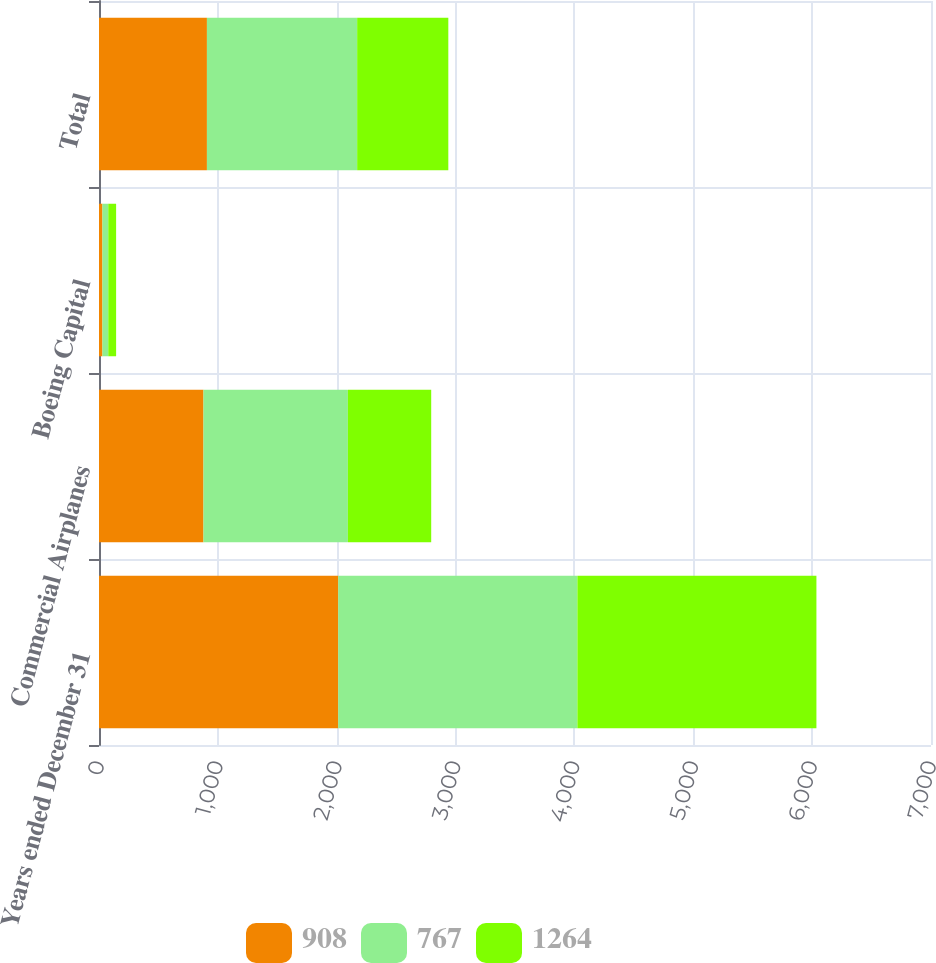Convert chart to OTSL. <chart><loc_0><loc_0><loc_500><loc_500><stacked_bar_chart><ecel><fcel>Years ended December 31<fcel>Commercial Airplanes<fcel>Boeing Capital<fcel>Total<nl><fcel>908<fcel>2013<fcel>879<fcel>29<fcel>908<nl><fcel>767<fcel>2012<fcel>1215<fcel>49<fcel>1264<nl><fcel>1264<fcel>2011<fcel>701<fcel>66<fcel>767<nl></chart> 